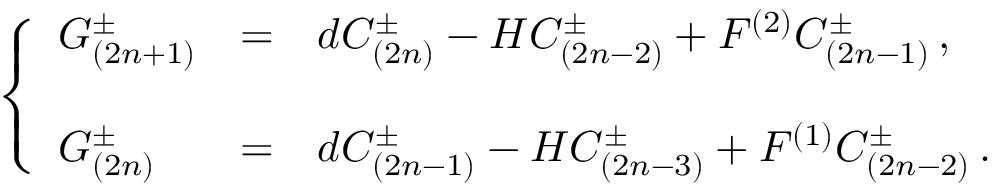Convert formula to latex. <formula><loc_0><loc_0><loc_500><loc_500>\left \{ \begin{array} { l c l } { { G _ { ( 2 n + 1 ) } ^ { \pm } } } & { = } & { { d C _ { ( 2 n ) } ^ { \pm } - H C _ { ( 2 n - 2 ) } ^ { \pm } + F ^ { ( 2 ) } C _ { ( 2 n - 1 ) } ^ { \pm } \, , } } \\ { { G _ { ( 2 n ) } ^ { \pm } } } & { = } & { { d C _ { ( 2 n - 1 ) } ^ { \pm } - H C _ { ( 2 n - 3 ) } ^ { \pm } + F ^ { ( 1 ) } C _ { ( 2 n - 2 ) } ^ { \pm } \, . } } \end{array}</formula> 